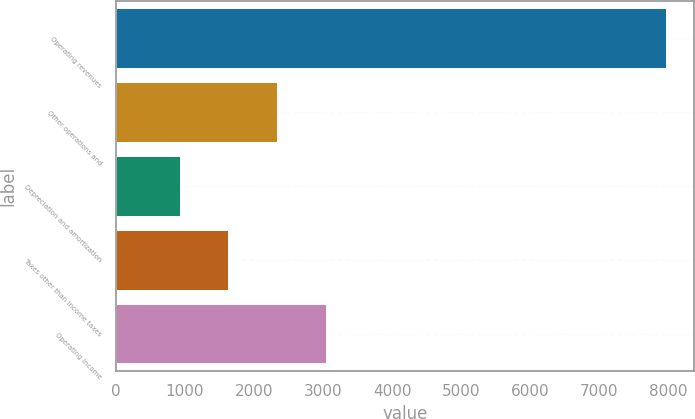Convert chart. <chart><loc_0><loc_0><loc_500><loc_500><bar_chart><fcel>Operating revenues<fcel>Other operations and<fcel>Depreciation and amortization<fcel>Taxes other than income taxes<fcel>Operating income<nl><fcel>7972<fcel>2334.4<fcel>925<fcel>1629.7<fcel>3039.1<nl></chart> 